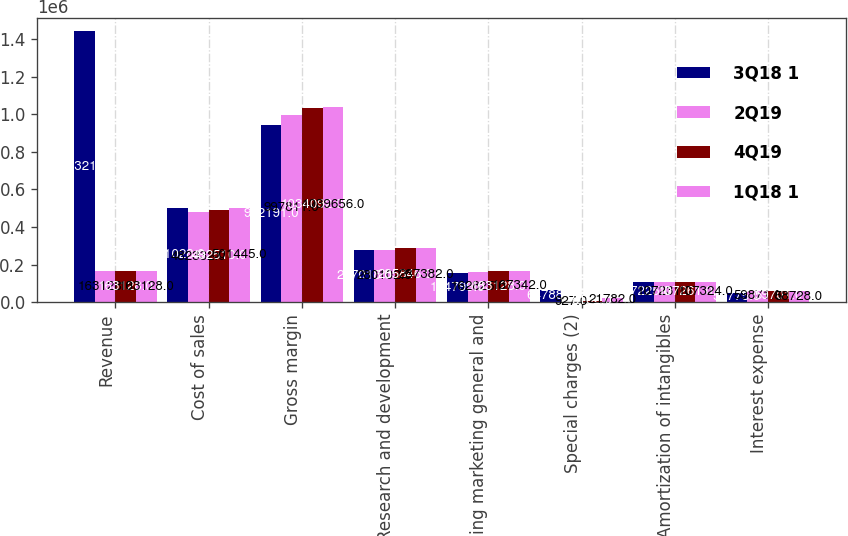Convert chart to OTSL. <chart><loc_0><loc_0><loc_500><loc_500><stacked_bar_chart><ecel><fcel>Revenue<fcel>Cost of sales<fcel>Gross margin<fcel>Research and development<fcel>Selling marketing general and<fcel>Special charges (2)<fcel>Amortization of intangibles<fcel>Interest expense<nl><fcel>3Q18 1<fcel>1.44322e+06<fcel>501028<fcel>942191<fcel>277018<fcel>154799<fcel>64788<fcel>107225<fcel>50775<nl><fcel>2Q19<fcel>163128<fcel>482332<fcel>997811<fcel>280102<fcel>162825<fcel>927<fcel>107231<fcel>59871<nl><fcel>4Q19<fcel>163128<fcel>492510<fcel>1.03409e+06<fcel>285846<fcel>163128<fcel>8162<fcel>107261<fcel>59701<nl><fcel>1Q18 1<fcel>163128<fcel>501445<fcel>1.03966e+06<fcel>287382<fcel>167342<fcel>21782<fcel>107324<fcel>58728<nl></chart> 